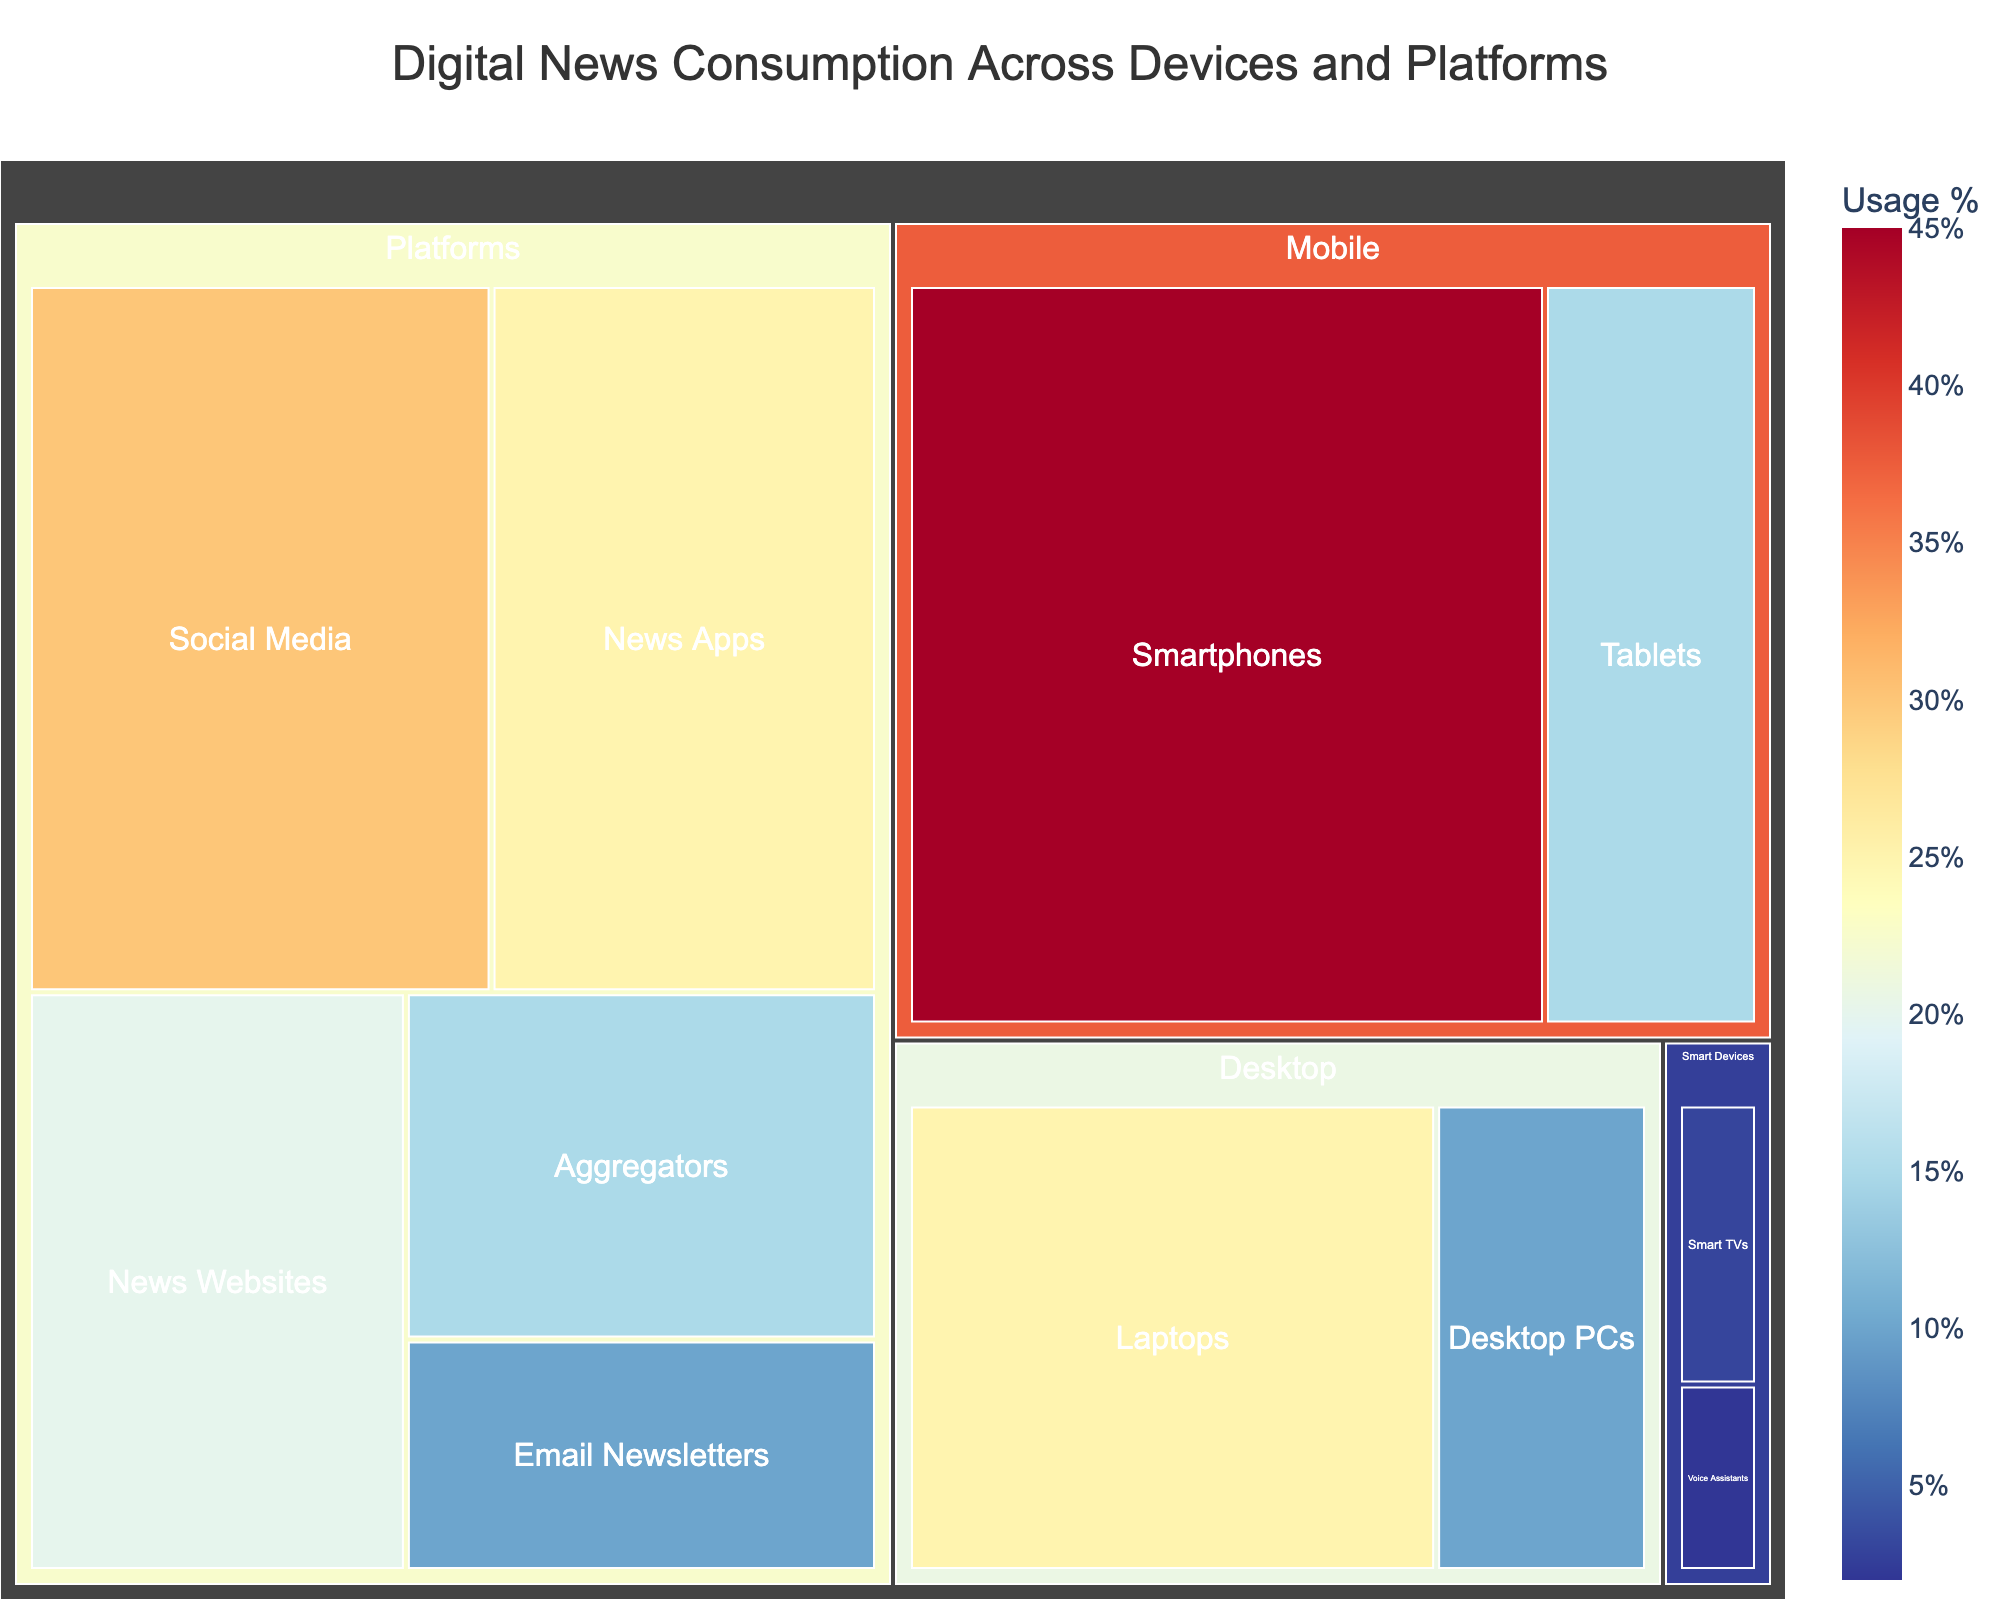What is the title of the treemap? The title of the treemap is prominently displayed at the top center of the visualization.
Answer: Digital News Consumption Across Devices and Platforms Which category contributes the most to digital news consumption? By examining the sizes of the different sections of the treemap, the category with the largest area represents the highest contribution to digital news consumption.
Answer: Mobile What percentage of news consumption comes from Smartphones? The usage percentage is displayed when you hover over or view the specific section for Smartphones under the Mobile category.
Answer: 45% How much higher is the consumption of Smart TVs compared to Voice Assistants? Find the usage percentage for both Smart TVs (3%) and Voice Assistants (2%), then subtract the smaller value from the larger one (3% - 2%).
Answer: 1% Which platform under the Platforms category has the highest usage? Look at the sizes of the sections under the Platforms category; the platform with the largest area represents the highest usage.
Answer: Social Media What is the combined percentage of news consumption through Tablets and Laptops? Tablets have 15% and Laptops have 25%. Adding these together gives 15% + 25%.
Answer: 40% Which has more usage: News Apps or Aggregators? Compare the sizes or hover over the sections for News Apps (25%) and Aggregators (15%) under Platforms; the larger value indicates more usage.
Answer: News Apps What's the total percentage of news consumption through Smart Devices? Smart TVs contribute 3% and Voice Assistants 2%; their sum is 3% + 2%.
Answer: 5% How does the usage of News Websites compare to Email Newsletters? Look at the usage percentages for both News Websites (20%) and Email Newsletters (10%) under Platforms and subtract the smaller from the larger value (20% - 10%).
Answer: 10% Which specific device/platform has the lowest news consumption percentage? By examining all the sections, the smallest area or lowest percentage value represents the lowest news consumption.
Answer: Voice Assistants 